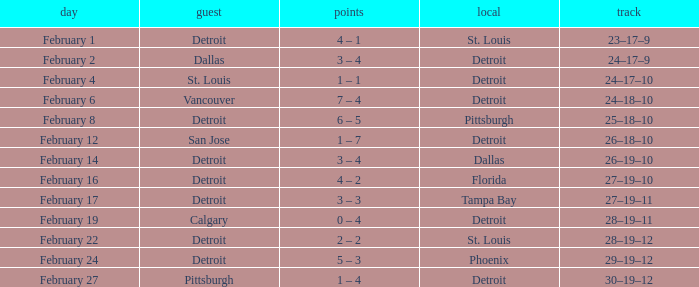What was their record when they were at Pittsburgh? 25–18–10. 